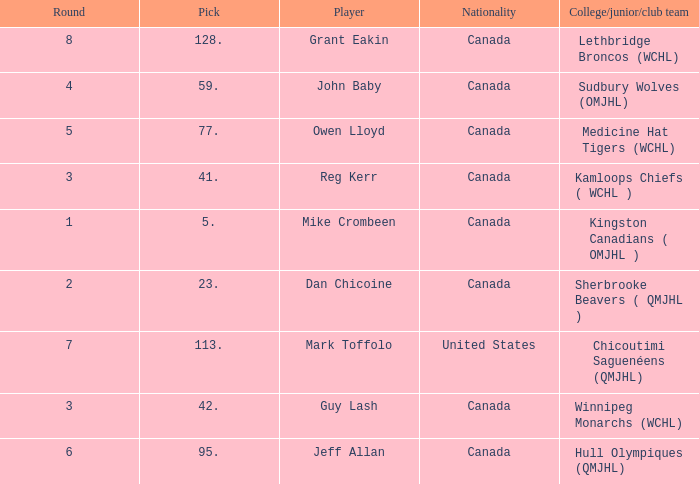Which College/junior/club team has a Round of 2? Sherbrooke Beavers ( QMJHL ). 